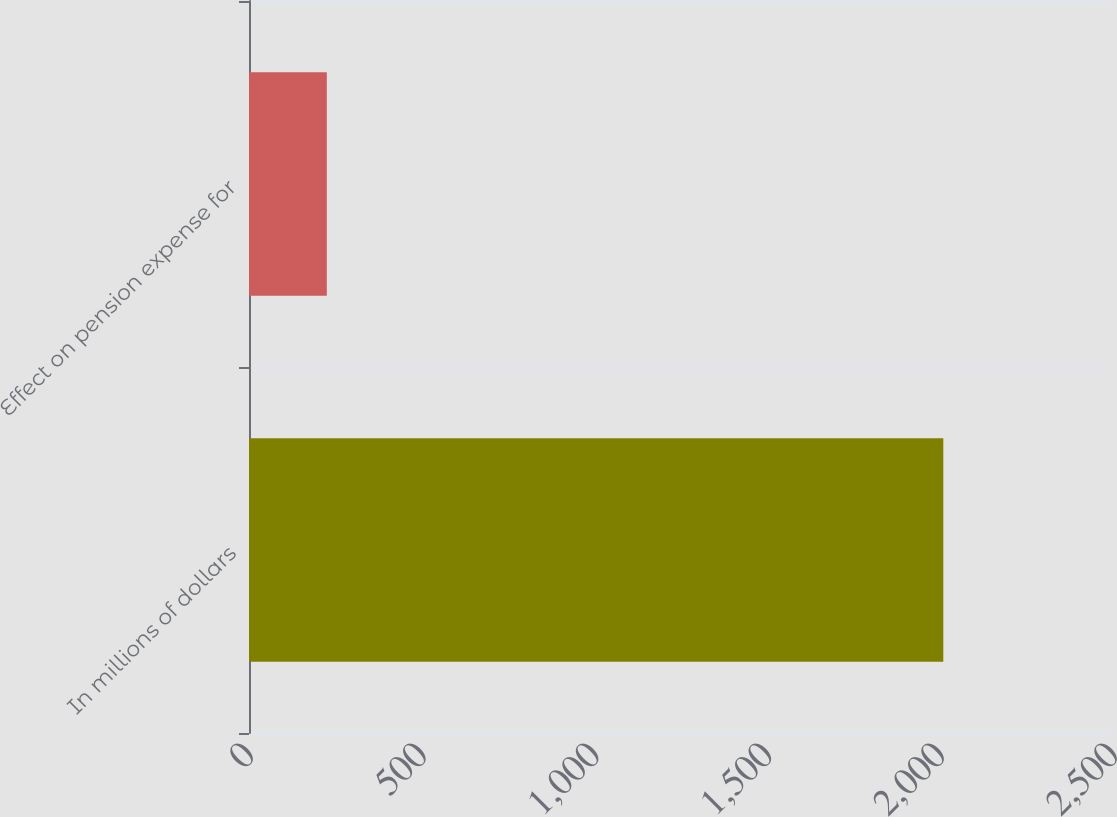<chart> <loc_0><loc_0><loc_500><loc_500><bar_chart><fcel>In millions of dollars<fcel>Effect on pension expense for<nl><fcel>2009<fcel>225.2<nl></chart> 